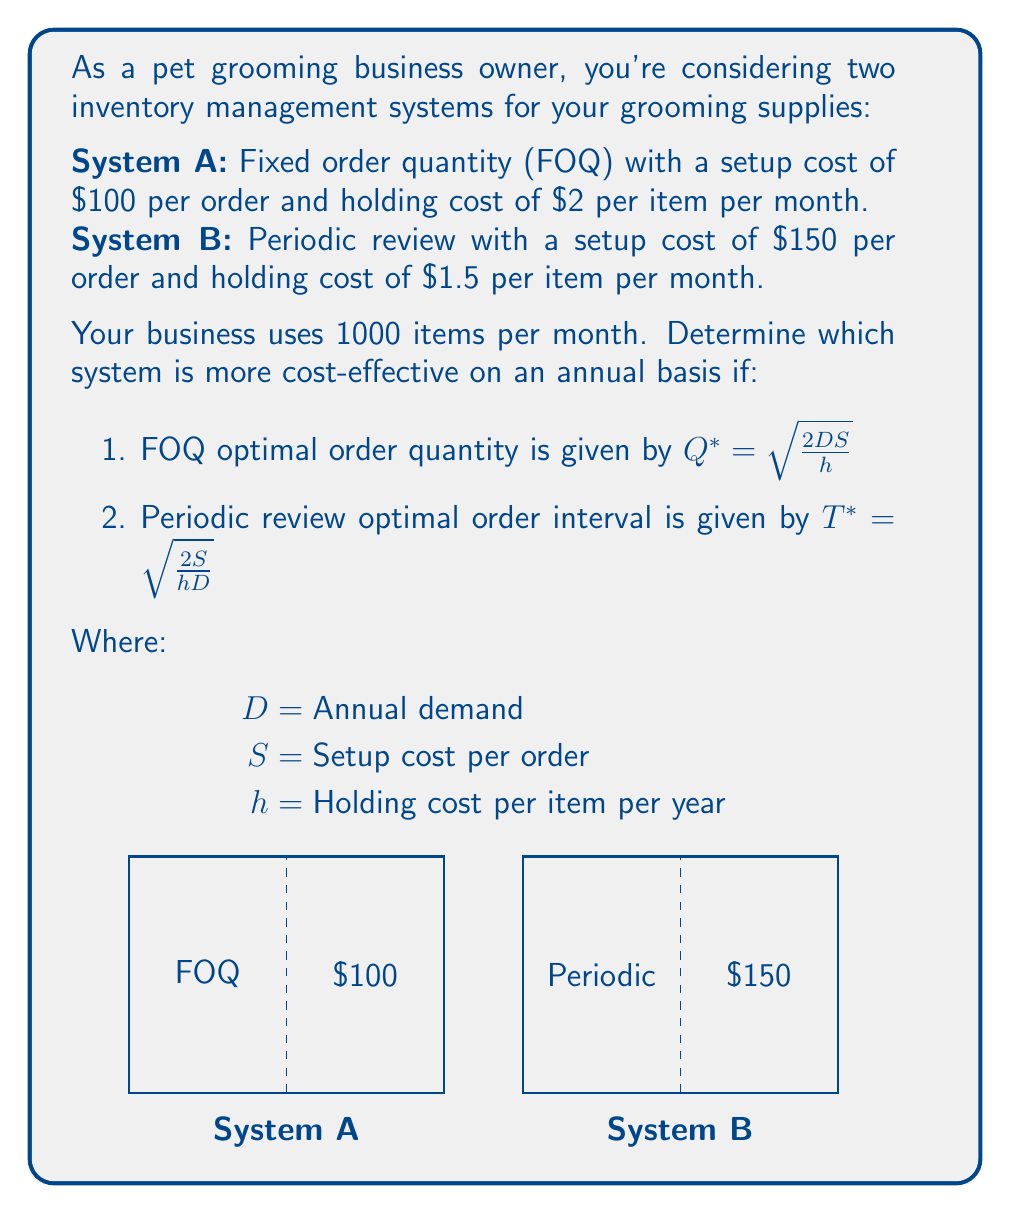Solve this math problem. Let's solve this problem step by step:

1. Calculate annual demand:
   $D = 1000 \text{ items/month} \times 12 \text{ months} = 12000 \text{ items/year}$

2. Convert monthly holding costs to annual:
   System A: $h_A = $2 \times 12 = $24 \text{ per item per year}$
   System B: $h_B = $1.5 \times 12 = $18 \text{ per item per year}$

3. For System A (FOQ):
   $$Q^* = \sqrt{\frac{2DS}{h}} = \sqrt{\frac{2 \times 12000 \times 100}{24}} = 316.23 \text{ items}$$

   Annual cost = Setup cost + Holding cost
   $$C_A = \frac{D}{Q^*}S + \frac{Q^*}{2}h = \frac{12000}{316.23} \times 100 + \frac{316.23}{2} \times 24 = $3794.73$$

4. For System B (Periodic review):
   $$T^* = \sqrt{\frac{2S}{hD}} = \sqrt{\frac{2 \times 150}{18 \times 12000}} = 0.0408 \text{ years } (14.9 \text{ days})$$

   Average inventory = $\frac{DT^*}{2} = \frac{12000 \times 0.0408}{2} = 244.95 \text{ items}$

   Annual cost = Setup cost + Holding cost
   $$C_B = \frac{S}{T^*} + \frac{DT^*}{2}h = \frac{150}{0.0408} + 244.95 \times 18 = $8084.10$$

5. Compare the annual costs:
   System A: $3794.73
   System B: $8084.10
Answer: System A (FOQ) is more cost-effective, saving $4289.37 annually. 